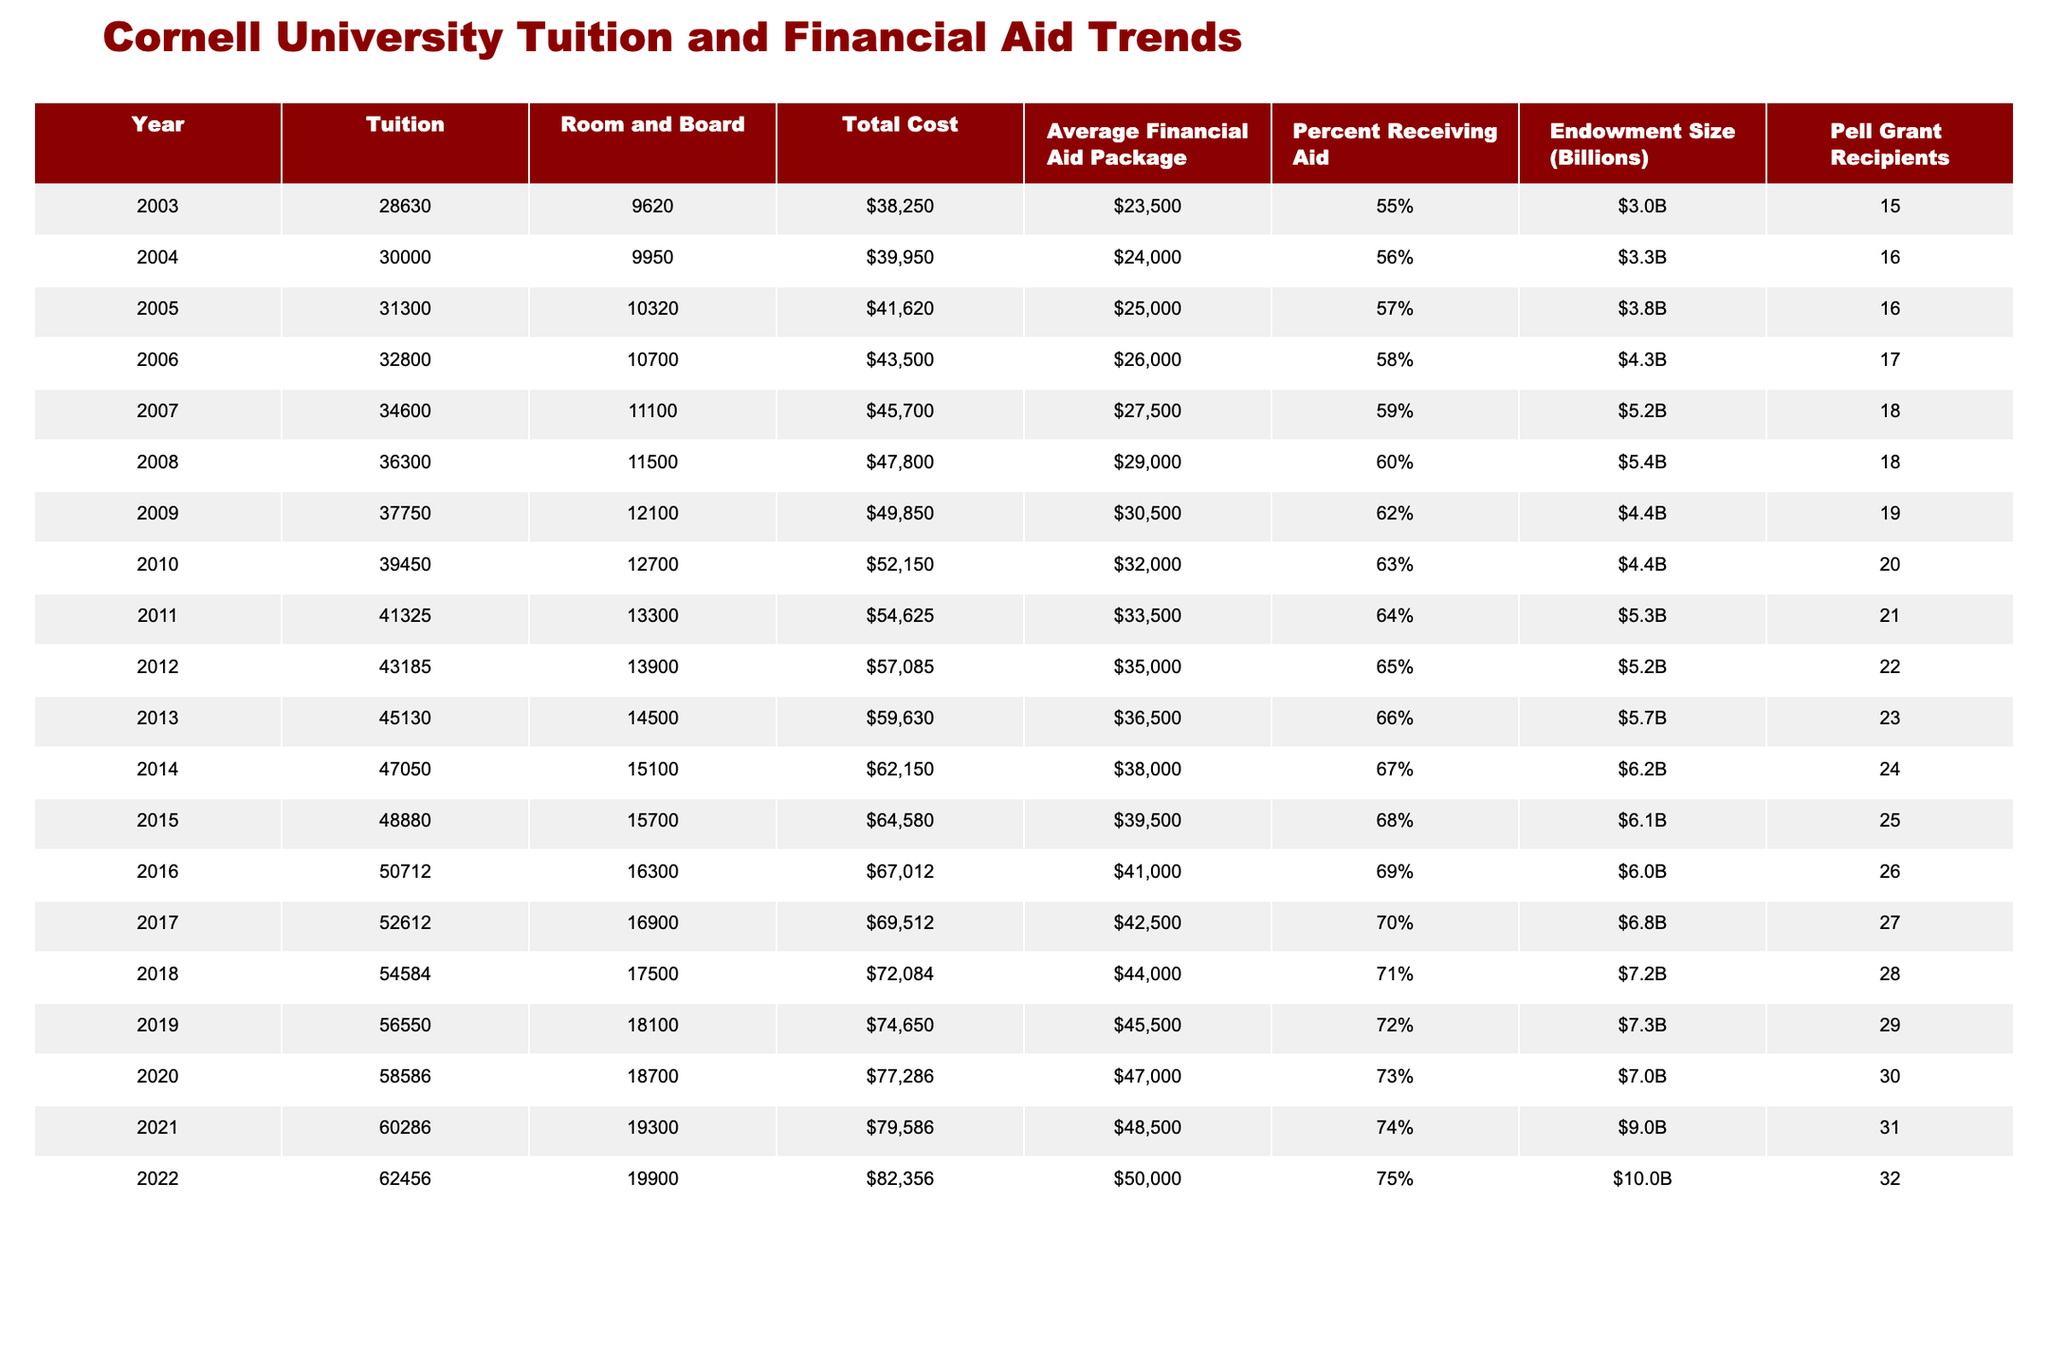What was the total cost of attendance in 2010? The total cost in 2010 is specifically provided in the table under the Total Cost column for that year, which lists it as 52150.
Answer: 52150 How much did the average financial aid package increase from 2003 to 2022? To determine the increase, subtract the average financial aid in 2003 (23500) from that in 2022 (50000). The calculation shows 50000 - 23500 = 26500.
Answer: 26500 Was the total cost of attendance higher in 2011 or 2012? The total costs in 2011 and 2012 are compared by looking at the respective values in the Total Cost column. In 2011, the total cost was 54625, and in 2012, it was 57085. Since 57085 is greater, 2012 had the higher cost.
Answer: 2012 What percentage of students received financial aid in 2015? The percentage of students receiving aid in 2015 is directly available in the Percent Receiving Aid column, where it shows 68%.
Answer: 68% What is the average endowment size from 2010 to 2022? The endowment sizes for 2010 to 2022 are read from the Endowment Size column, which lists the values as 4.4, 4.4, 5.3, 5.2, 6.2, 6.1, 6.0, 6.8, 7.2, 7.3, 7.0, 9.0, 10.0. These values are summed up (totaling 66.4) and then divided by the number of years (13), yielding an average of approximately 5.1.
Answer: 5.1 Was there a year when both tuition and room and board decreased compared to the previous year? By examining the Tuition and Room and Board columns sequentially, it is found that there are no instances where both values decreased in any year compared to the previous year; they consistently either increased or remained the same.
Answer: No What was the difference in total cost between 2008 and 2014? The total costs for 2008 and 2014 can be found directly in the Total Cost column: for 2008, it is 47800 and for 2014, it is 62150. To find the difference, subtract the value from 2008 from the value from 2014: 62150 - 47800 = 14350.
Answer: 14350 Which year had the highest number of Pell Grant recipients, and how many were there? To find the year with the highest number of Pell Grant recipients, the values in the Pell Grant Recipients column are checked. The maximum number appears in 2022 with 32 recipients.
Answer: 2022, 32 By how much did the average financial aid package and total cost grow between 2010 and 2022? The average financial aid package in 2010 was 32000, and in 2022 it was 50000, resulting in a growth of 50000 - 32000 = 18000. The total cost in 2010 was 52150, and in 2022 it was 82356, resulting in growth of 82356 - 52150 = 30206. This shows both values’ growth from 2010 to 2022.
Answer: 18000 for aid package, 30206 for total cost 